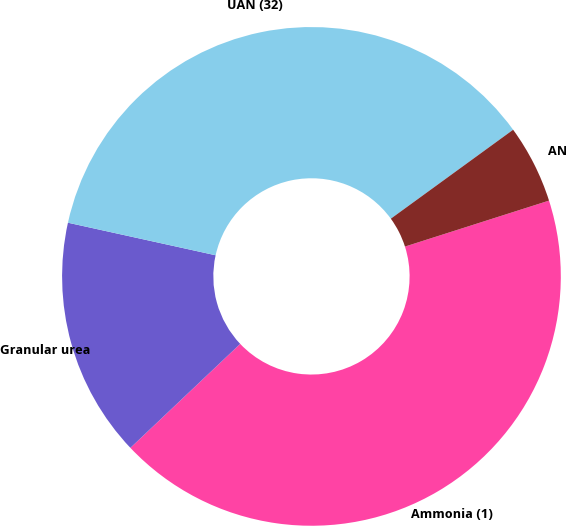Convert chart to OTSL. <chart><loc_0><loc_0><loc_500><loc_500><pie_chart><fcel>Ammonia (1)<fcel>Granular urea<fcel>UAN (32)<fcel>AN<nl><fcel>42.85%<fcel>15.52%<fcel>36.54%<fcel>5.09%<nl></chart> 